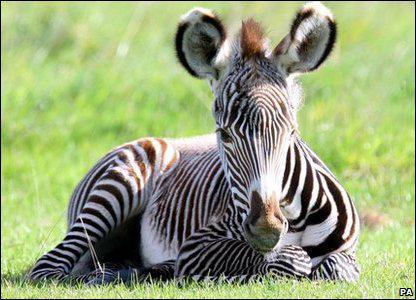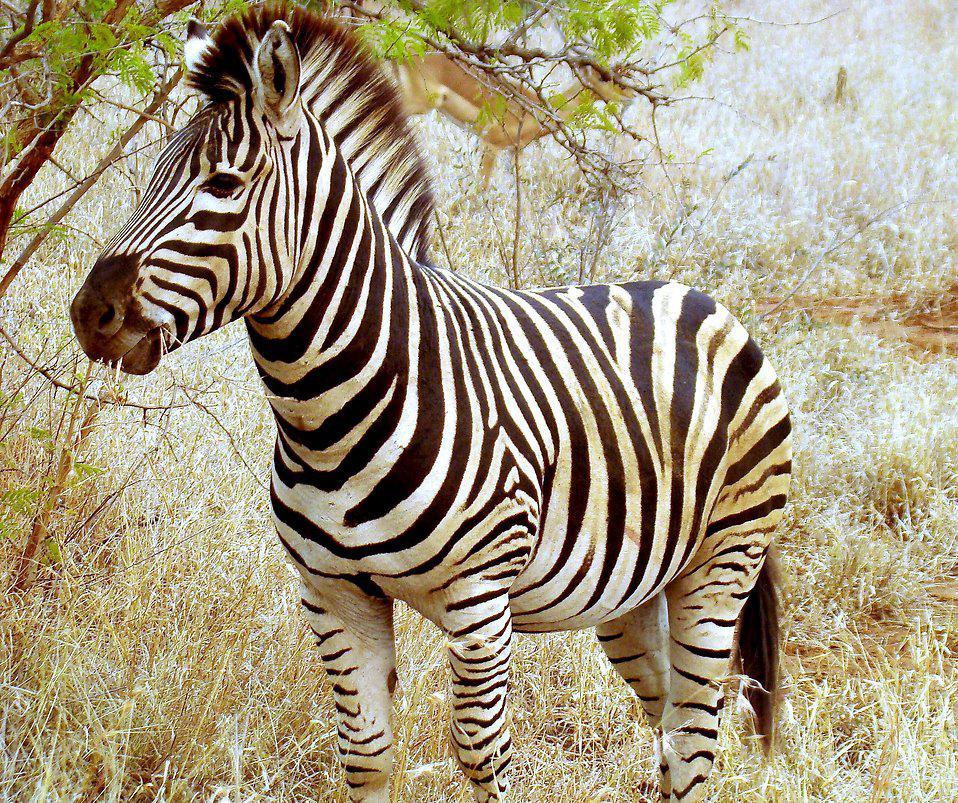The first image is the image on the left, the second image is the image on the right. Assess this claim about the two images: "One image has a zebra laying on the ground.". Correct or not? Answer yes or no. Yes. 